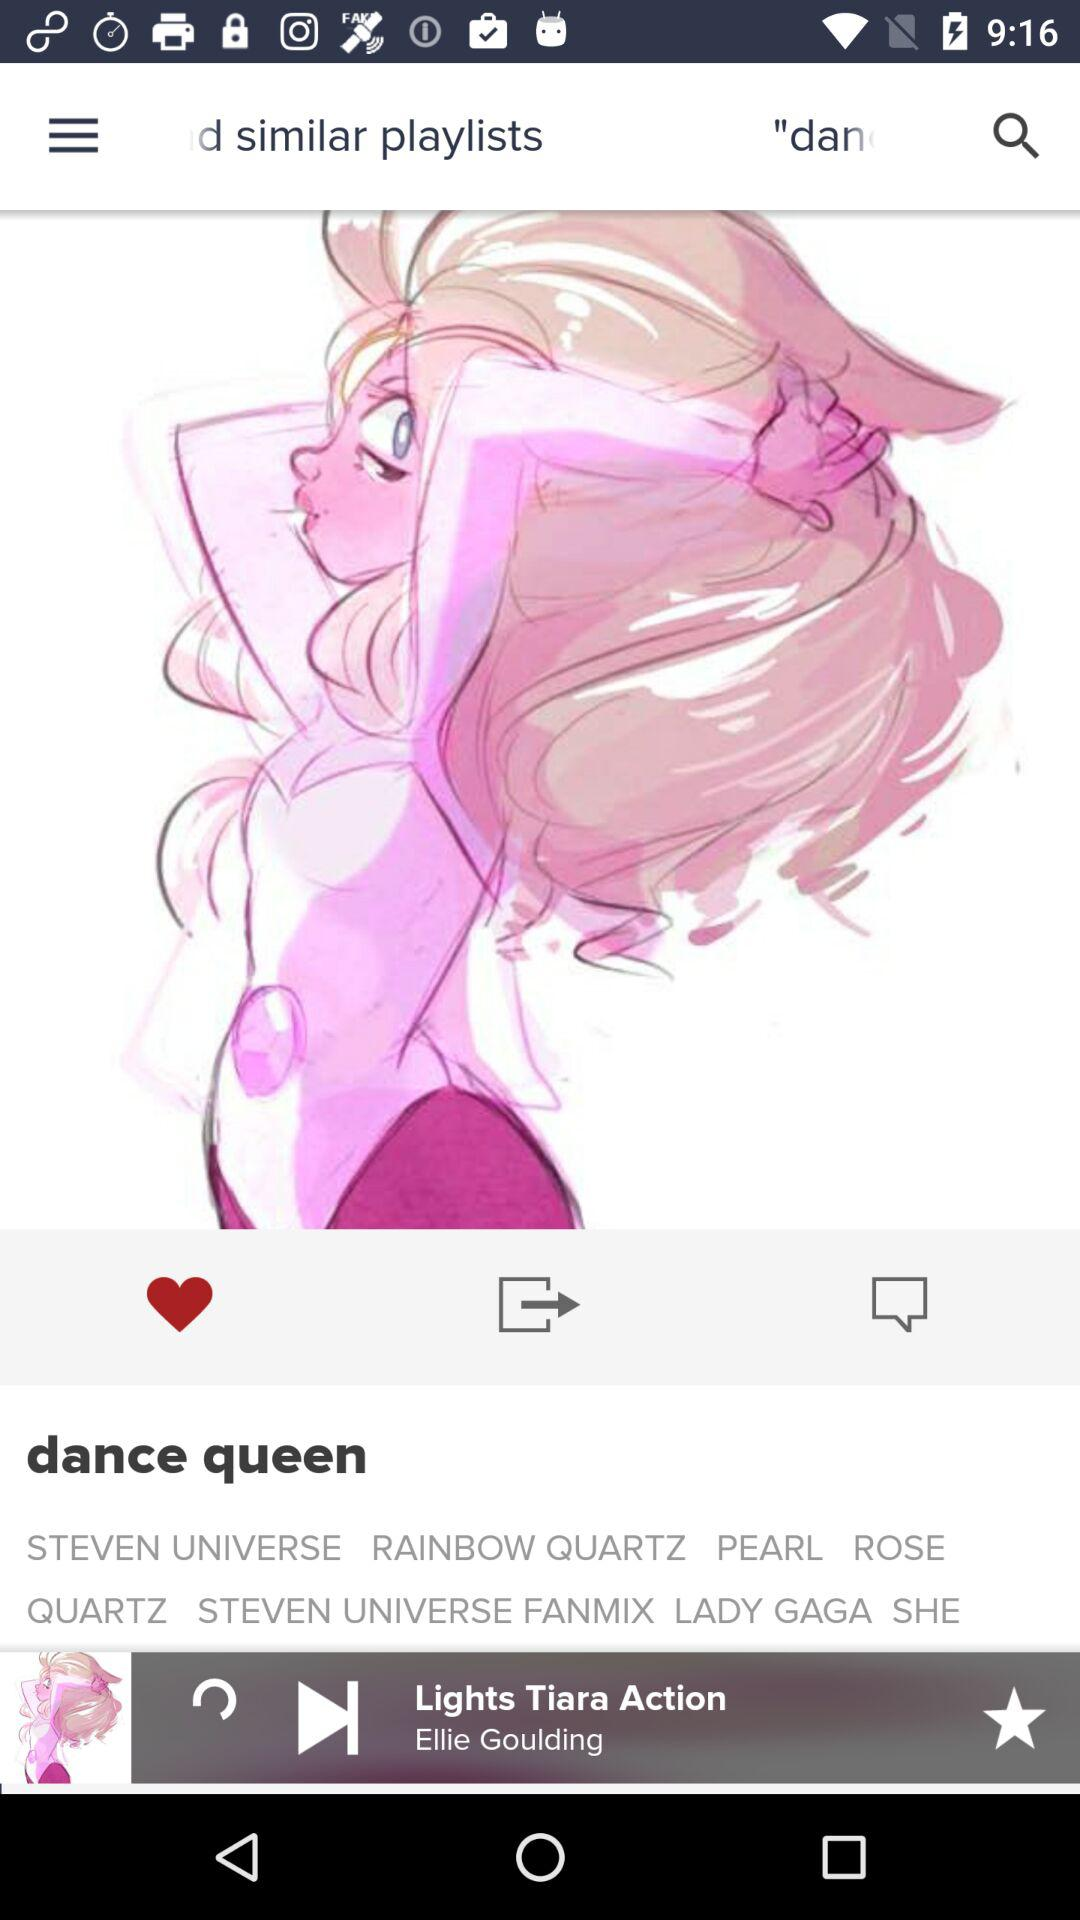What's the name of the album? The name of the album is "dance queen". 